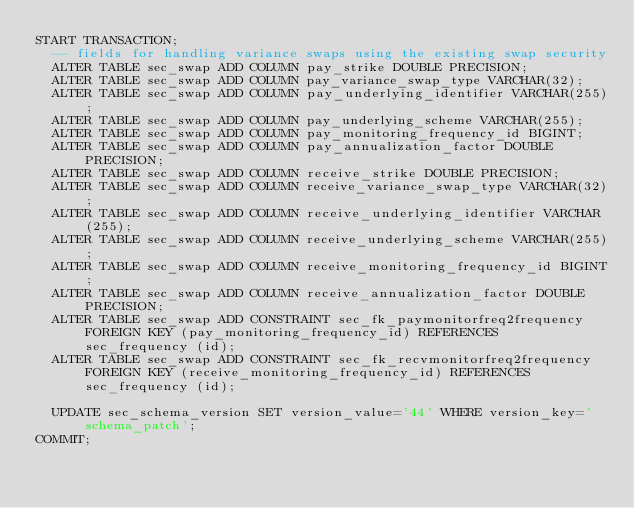Convert code to text. <code><loc_0><loc_0><loc_500><loc_500><_SQL_>START TRANSACTION;
  -- fields for handling variance swaps using the existing swap security
  ALTER TABLE sec_swap ADD COLUMN pay_strike DOUBLE PRECISION;
  ALTER TABLE sec_swap ADD COLUMN pay_variance_swap_type VARCHAR(32);
  ALTER TABLE sec_swap ADD COLUMN pay_underlying_identifier VARCHAR(255);
  ALTER TABLE sec_swap ADD COLUMN pay_underlying_scheme VARCHAR(255);
  ALTER TABLE sec_swap ADD COLUMN pay_monitoring_frequency_id BIGINT;
  ALTER TABLE sec_swap ADD COLUMN pay_annualization_factor DOUBLE PRECISION;
  ALTER TABLE sec_swap ADD COLUMN receive_strike DOUBLE PRECISION;
  ALTER TABLE sec_swap ADD COLUMN receive_variance_swap_type VARCHAR(32);
  ALTER TABLE sec_swap ADD COLUMN receive_underlying_identifier VARCHAR(255);
  ALTER TABLE sec_swap ADD COLUMN receive_underlying_scheme VARCHAR(255);
  ALTER TABLE sec_swap ADD COLUMN receive_monitoring_frequency_id BIGINT;
  ALTER TABLE sec_swap ADD COLUMN receive_annualization_factor DOUBLE PRECISION;
  ALTER TABLE sec_swap ADD CONSTRAINT sec_fk_paymonitorfreq2frequency FOREIGN KEY (pay_monitoring_frequency_id) REFERENCES sec_frequency (id);
  ALTER TABLE sec_swap ADD CONSTRAINT sec_fk_recvmonitorfreq2frequency FOREIGN KEY (receive_monitoring_frequency_id) REFERENCES sec_frequency (id);

  UPDATE sec_schema_version SET version_value='44' WHERE version_key='schema_patch';
COMMIT;</code> 